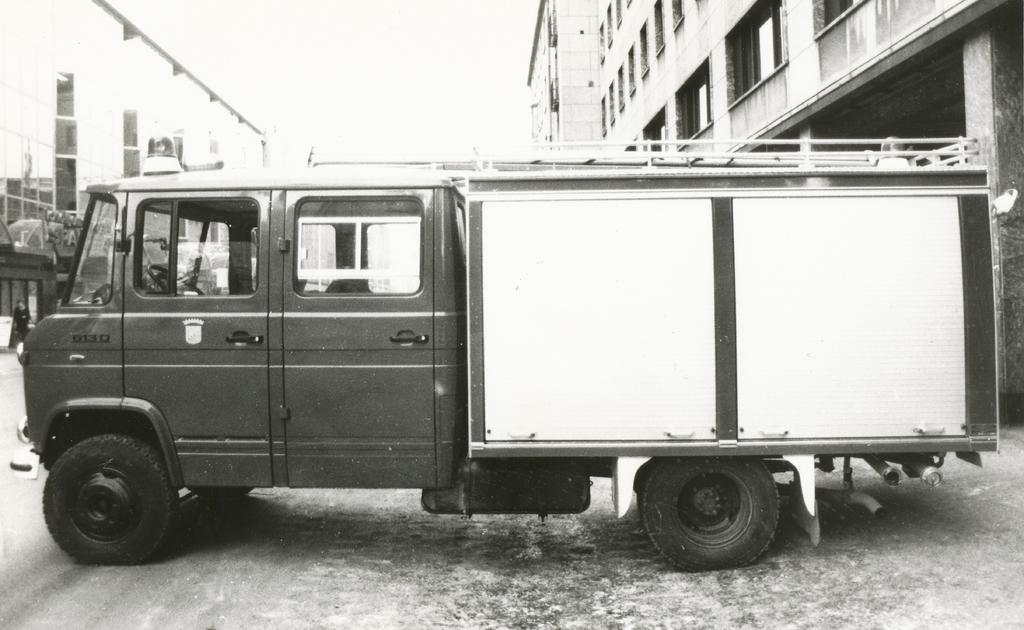What is the main subject of the image? There is a vehicle in the image. Where is the vehicle located? The vehicle is on the road. What can be seen in the background of the image? There are buildings and the sky visible in the background of the image. What type of frog can be seen hopping on the roof of the vehicle in the image? There is no frog present in the image, and therefore no such activity can be observed. 